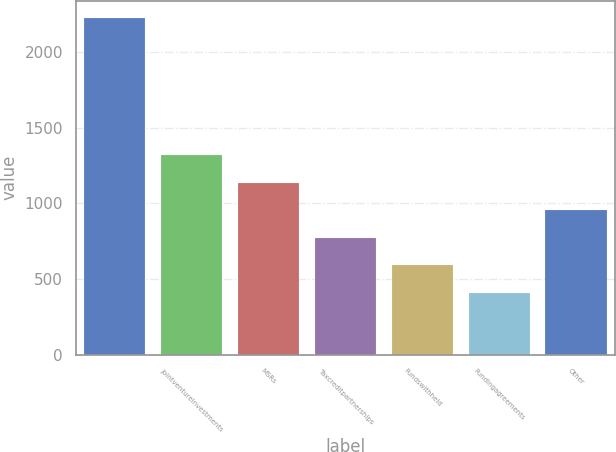Convert chart to OTSL. <chart><loc_0><loc_0><loc_500><loc_500><bar_chart><ecel><fcel>Jointventureinvestments<fcel>MSRs<fcel>Taxcreditpartnerships<fcel>Fundswithheld<fcel>Fundingagreements<fcel>Other<nl><fcel>2227<fcel>1318<fcel>1136.2<fcel>772.6<fcel>590.8<fcel>409<fcel>954.4<nl></chart> 